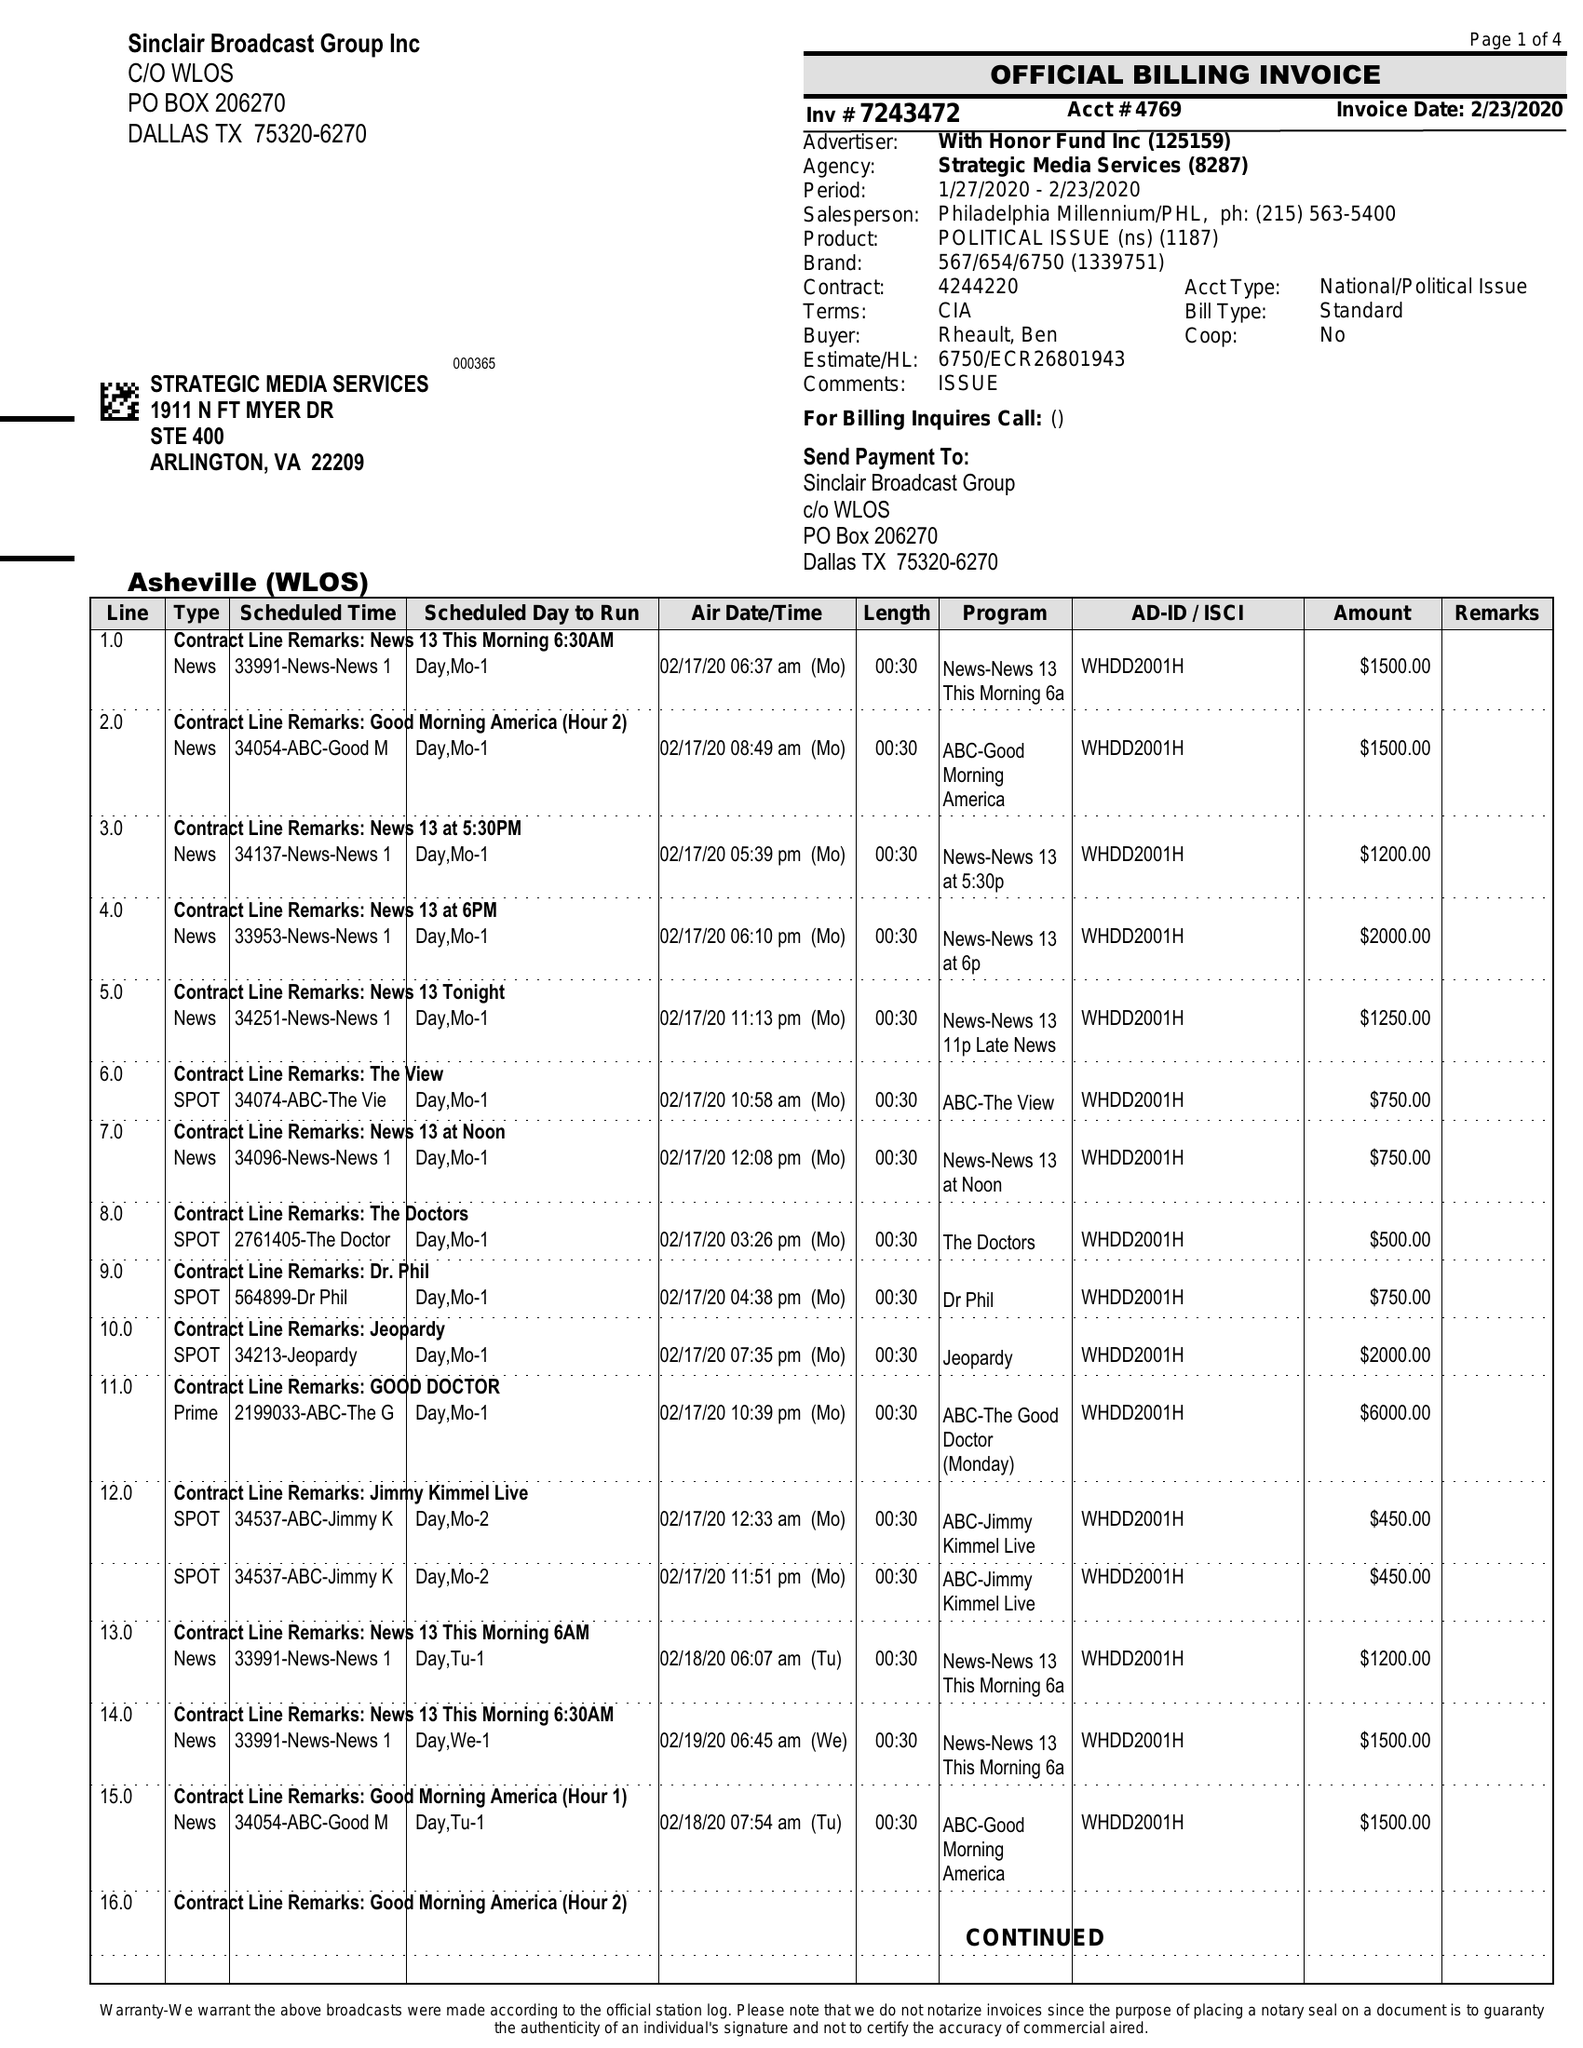What is the value for the advertiser?
Answer the question using a single word or phrase. WITH HONOR FUND INC 